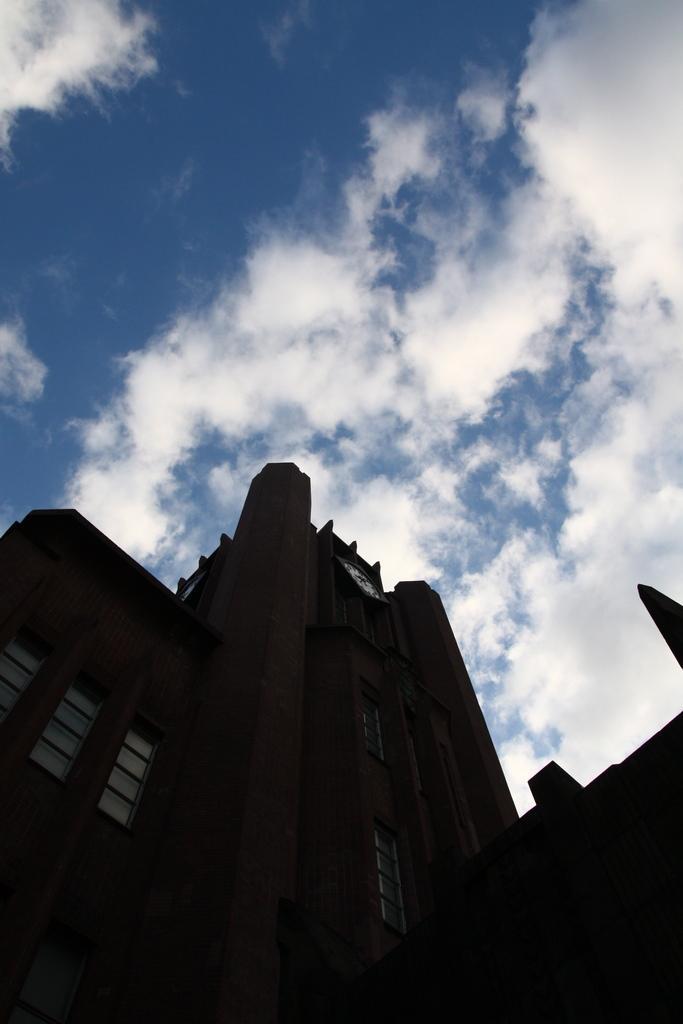Please provide a concise description of this image. In this image we can see a building with windows and a clock. In the background, we can see cloudy sky. 